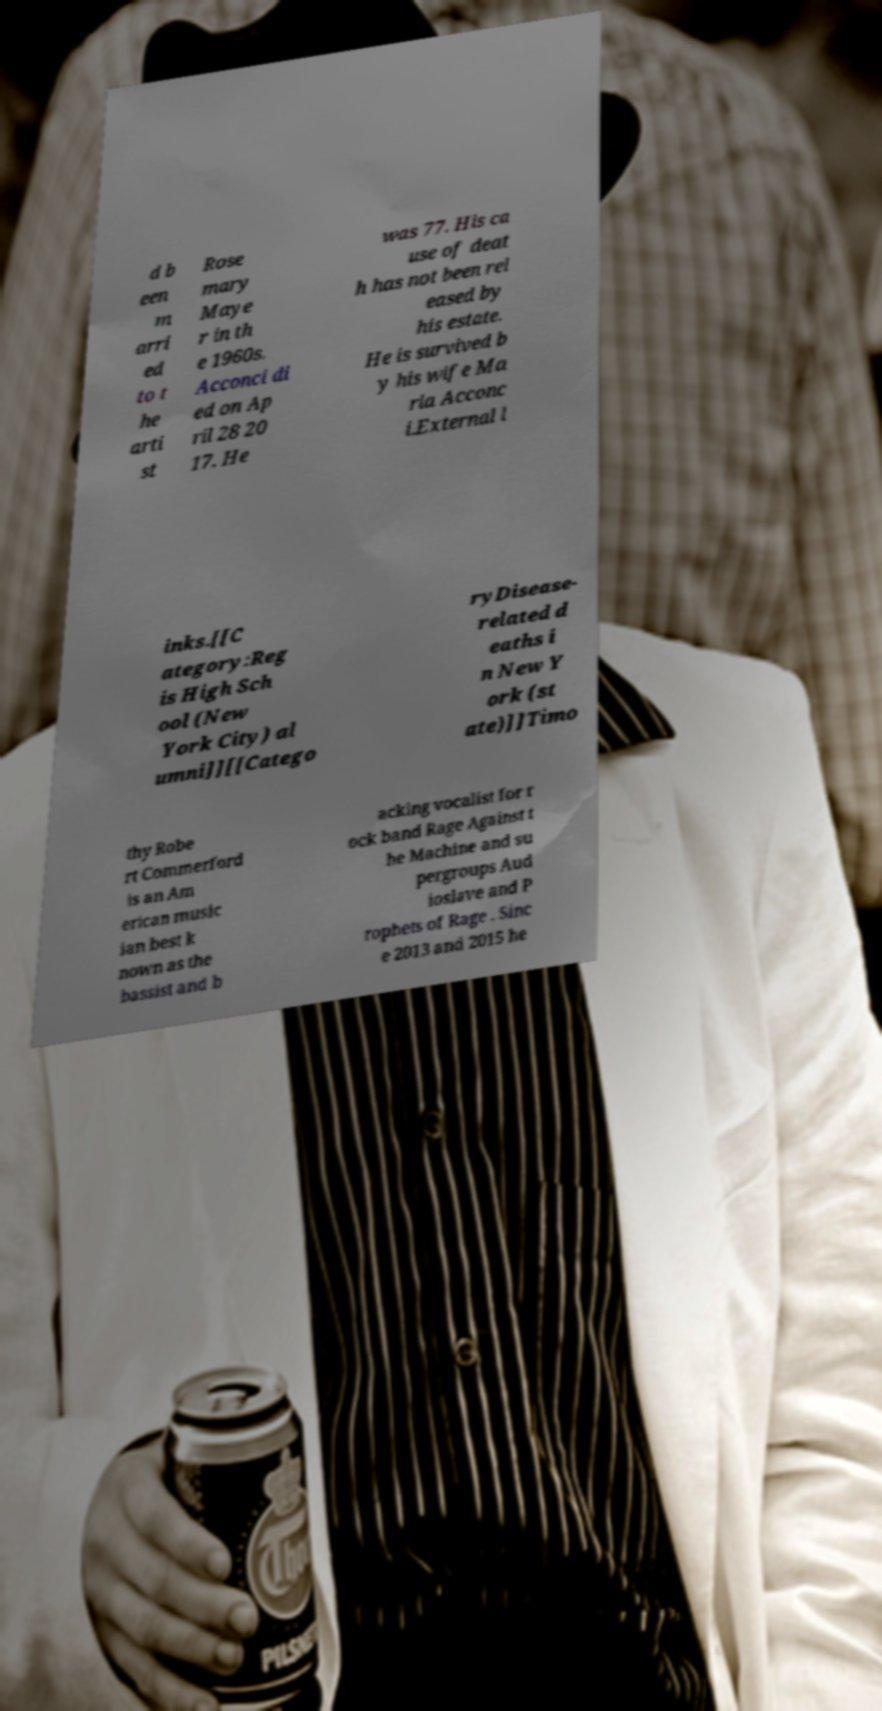There's text embedded in this image that I need extracted. Can you transcribe it verbatim? d b een m arri ed to t he arti st Rose mary Maye r in th e 1960s. Acconci di ed on Ap ril 28 20 17. He was 77. His ca use of deat h has not been rel eased by his estate. He is survived b y his wife Ma ria Acconc i.External l inks.[[C ategory:Reg is High Sch ool (New York City) al umni]][[Catego ryDisease- related d eaths i n New Y ork (st ate)]]Timo thy Robe rt Commerford is an Am erican music ian best k nown as the bassist and b acking vocalist for r ock band Rage Against t he Machine and su pergroups Aud ioslave and P rophets of Rage . Sinc e 2013 and 2015 he 